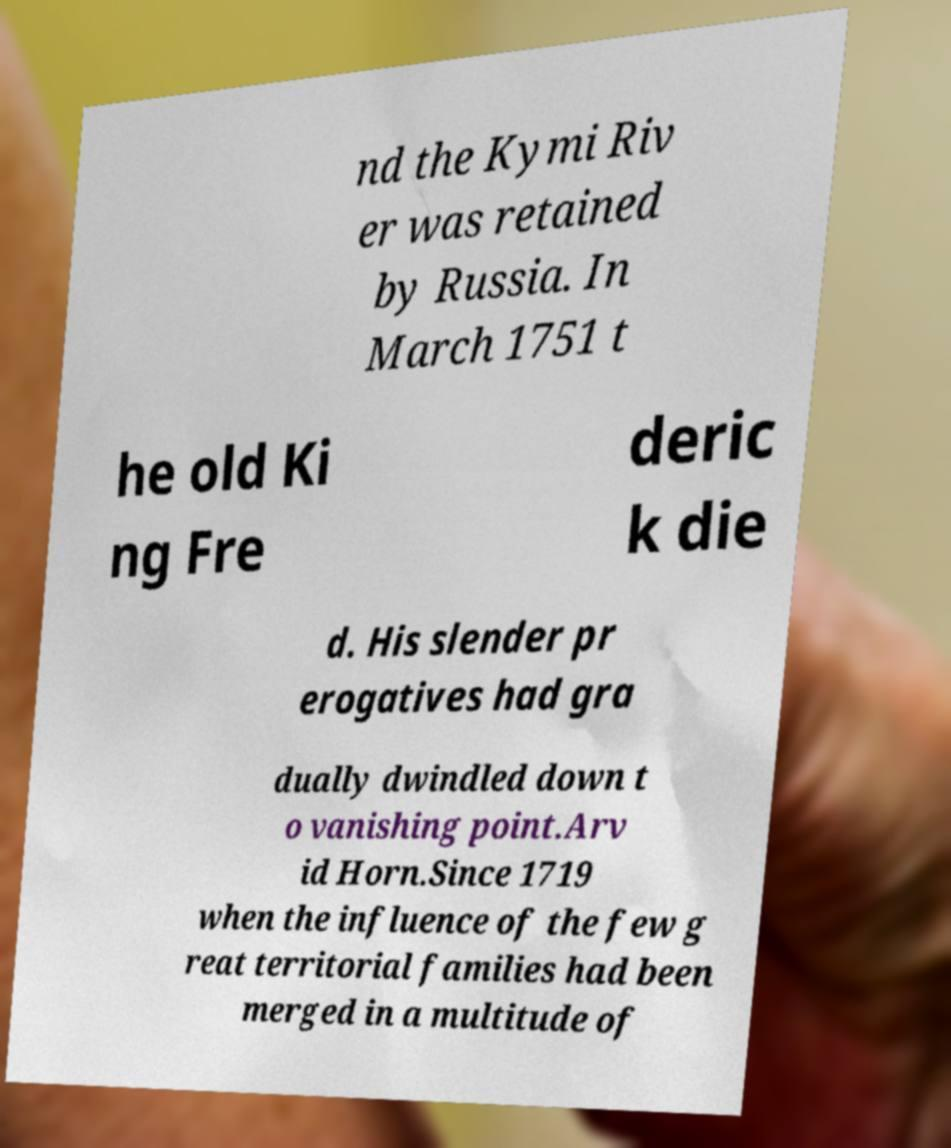Please read and relay the text visible in this image. What does it say? nd the Kymi Riv er was retained by Russia. In March 1751 t he old Ki ng Fre deric k die d. His slender pr erogatives had gra dually dwindled down t o vanishing point.Arv id Horn.Since 1719 when the influence of the few g reat territorial families had been merged in a multitude of 